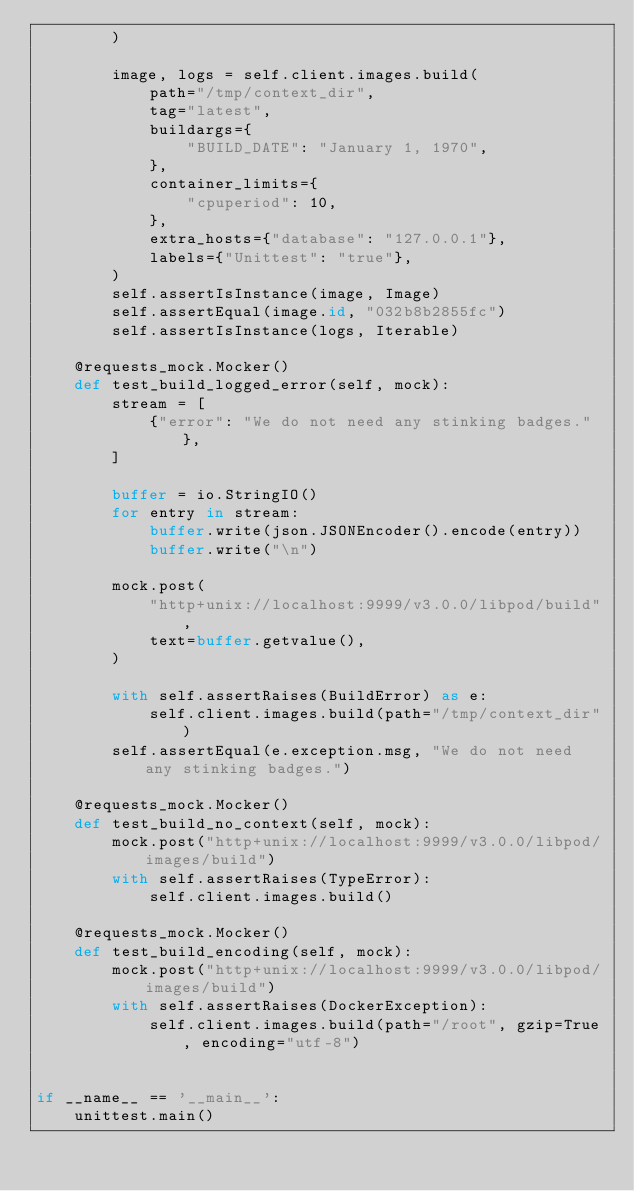<code> <loc_0><loc_0><loc_500><loc_500><_Python_>        )

        image, logs = self.client.images.build(
            path="/tmp/context_dir",
            tag="latest",
            buildargs={
                "BUILD_DATE": "January 1, 1970",
            },
            container_limits={
                "cpuperiod": 10,
            },
            extra_hosts={"database": "127.0.0.1"},
            labels={"Unittest": "true"},
        )
        self.assertIsInstance(image, Image)
        self.assertEqual(image.id, "032b8b2855fc")
        self.assertIsInstance(logs, Iterable)

    @requests_mock.Mocker()
    def test_build_logged_error(self, mock):
        stream = [
            {"error": "We do not need any stinking badges."},
        ]

        buffer = io.StringIO()
        for entry in stream:
            buffer.write(json.JSONEncoder().encode(entry))
            buffer.write("\n")

        mock.post(
            "http+unix://localhost:9999/v3.0.0/libpod/build",
            text=buffer.getvalue(),
        )

        with self.assertRaises(BuildError) as e:
            self.client.images.build(path="/tmp/context_dir")
        self.assertEqual(e.exception.msg, "We do not need any stinking badges.")

    @requests_mock.Mocker()
    def test_build_no_context(self, mock):
        mock.post("http+unix://localhost:9999/v3.0.0/libpod/images/build")
        with self.assertRaises(TypeError):
            self.client.images.build()

    @requests_mock.Mocker()
    def test_build_encoding(self, mock):
        mock.post("http+unix://localhost:9999/v3.0.0/libpod/images/build")
        with self.assertRaises(DockerException):
            self.client.images.build(path="/root", gzip=True, encoding="utf-8")


if __name__ == '__main__':
    unittest.main()
</code> 